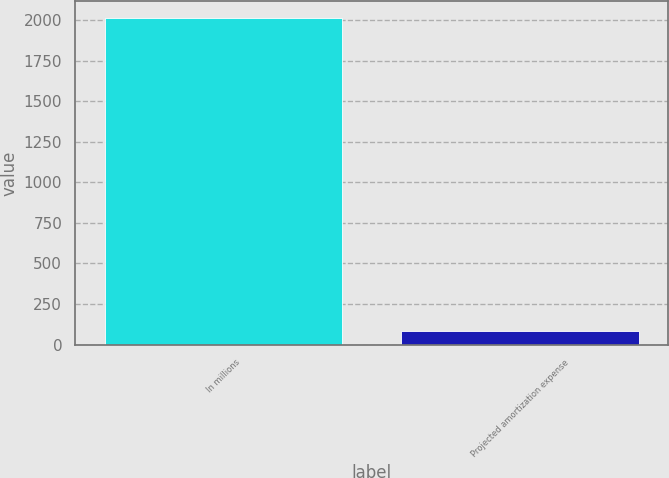Convert chart. <chart><loc_0><loc_0><loc_500><loc_500><bar_chart><fcel>In millions<fcel>Projected amortization expense<nl><fcel>2015<fcel>86<nl></chart> 